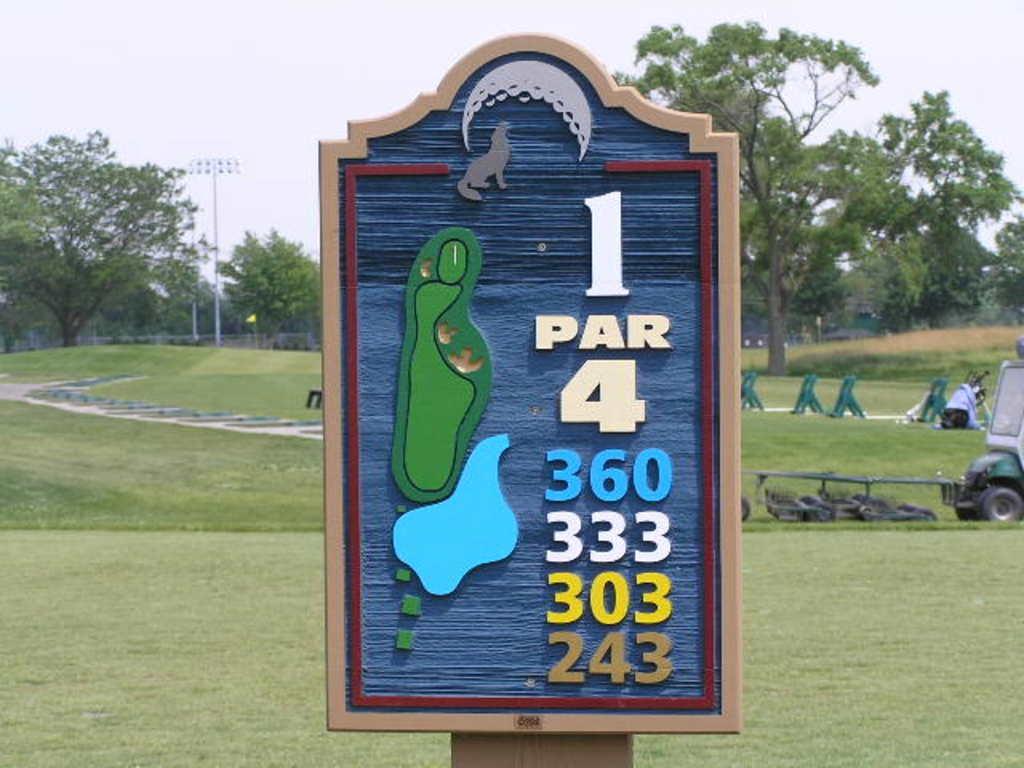Describe this image in one or two sentences. In this image we can see a board with some numbers. On the backside we can see a truck, benches, grass, trees, light to a pole, fence and the sky which looks cloudy. 